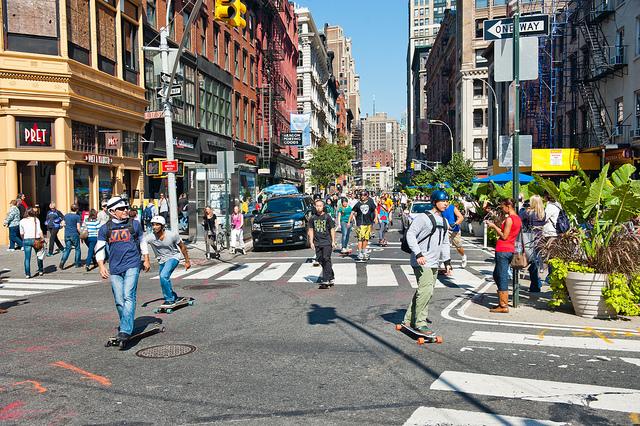Is it day or night?
Answer briefly. Day. Is this a city?
Quick response, please. Yes. How many skateboarders?
Short answer required. 6. 